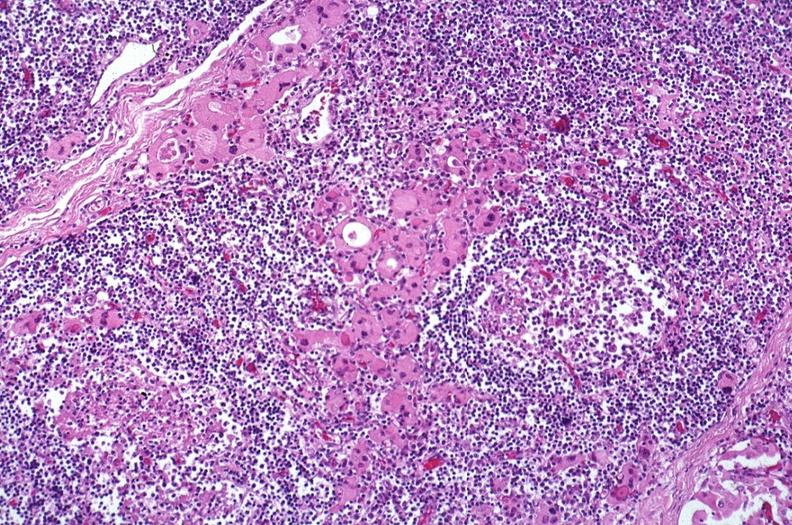does another fiber other frame show hashimoto 's thyroiditis?
Answer the question using a single word or phrase. No 